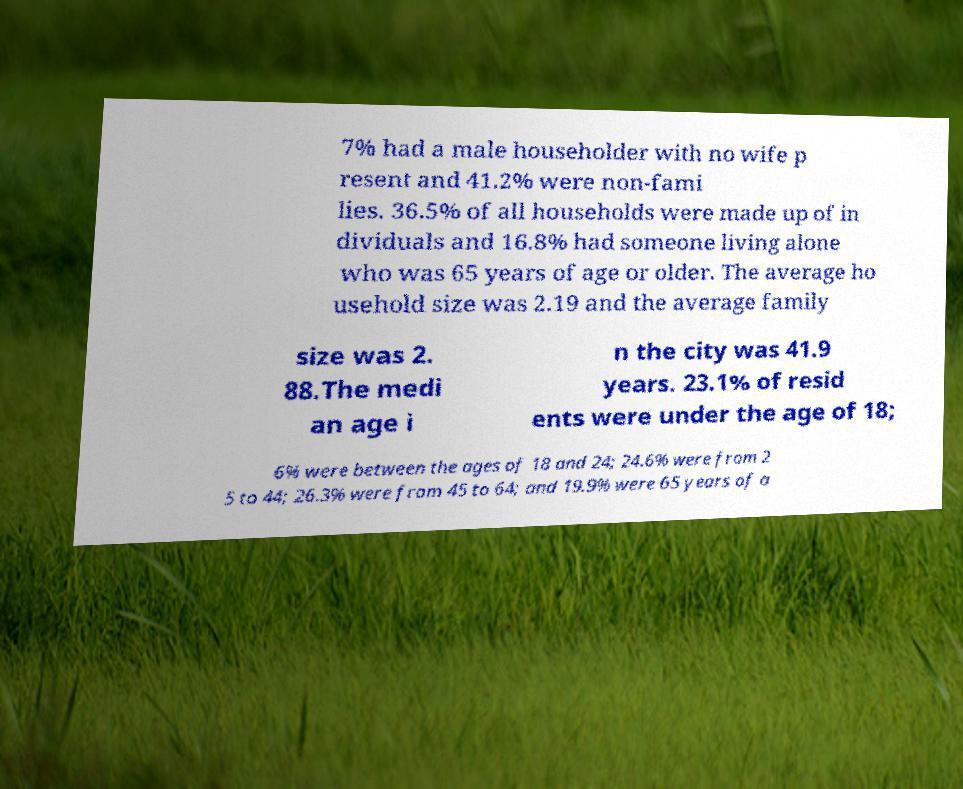Please identify and transcribe the text found in this image. 7% had a male householder with no wife p resent and 41.2% were non-fami lies. 36.5% of all households were made up of in dividuals and 16.8% had someone living alone who was 65 years of age or older. The average ho usehold size was 2.19 and the average family size was 2. 88.The medi an age i n the city was 41.9 years. 23.1% of resid ents were under the age of 18; 6% were between the ages of 18 and 24; 24.6% were from 2 5 to 44; 26.3% were from 45 to 64; and 19.9% were 65 years of a 